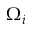<formula> <loc_0><loc_0><loc_500><loc_500>\Omega _ { i }</formula> 